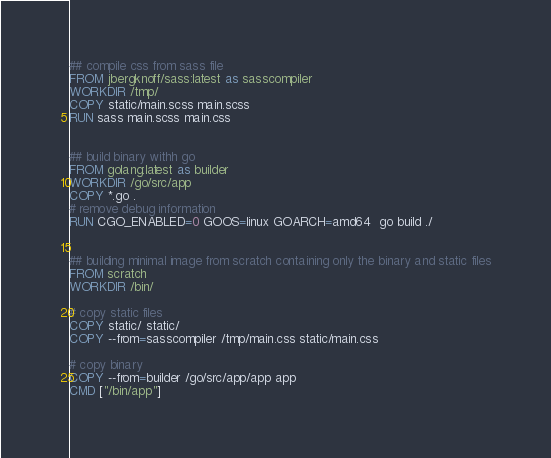Convert code to text. <code><loc_0><loc_0><loc_500><loc_500><_Dockerfile_>## compile css from sass file
FROM jbergknoff/sass:latest as sasscompiler
WORKDIR /tmp/
COPY static/main.scss main.scss
RUN sass main.scss main.css


## build binary withh go
FROM golang:latest as builder
WORKDIR /go/src/app
COPY *.go .
# remove debug information
RUN CGO_ENABLED=0 GOOS=linux GOARCH=amd64  go build ./


## building minimal image from scratch containing only the binary and static files
FROM scratch
WORKDIR /bin/

# copy static files
COPY static/ static/
COPY --from=sasscompiler /tmp/main.css static/main.css

# copy binary
COPY --from=builder /go/src/app/app app
CMD ["/bin/app"]</code> 